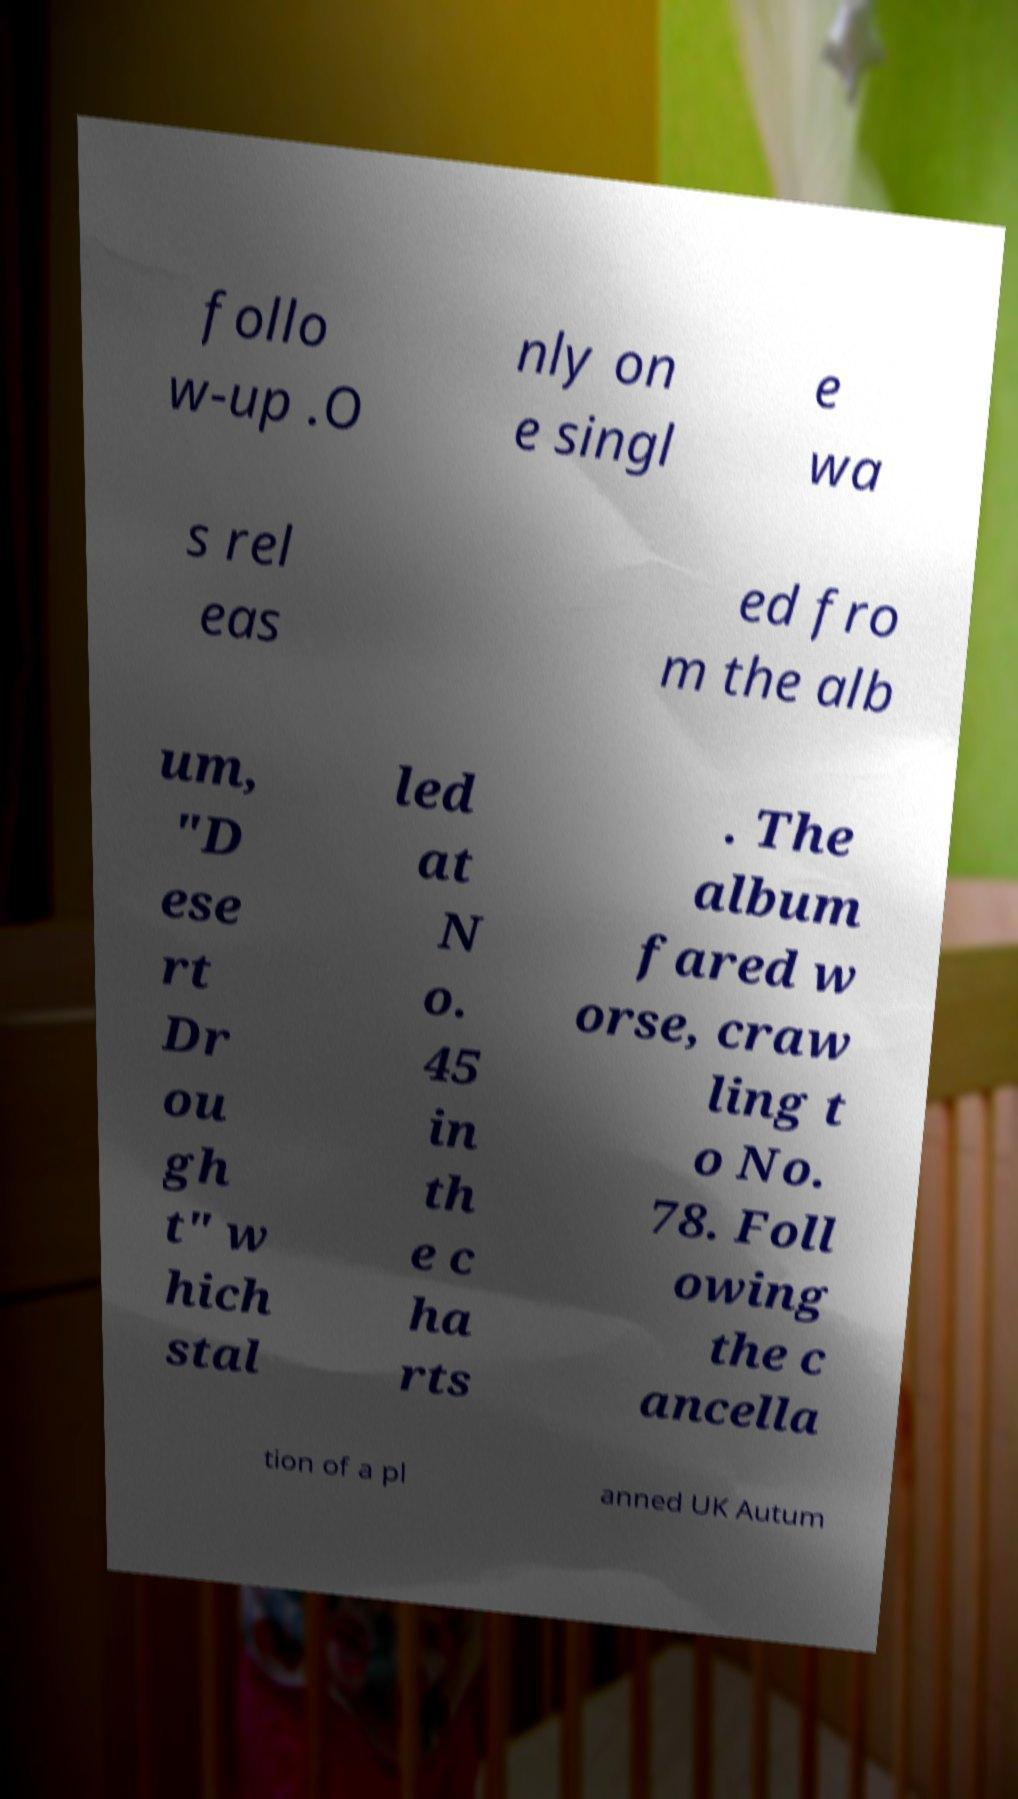There's text embedded in this image that I need extracted. Can you transcribe it verbatim? follo w-up .O nly on e singl e wa s rel eas ed fro m the alb um, "D ese rt Dr ou gh t" w hich stal led at N o. 45 in th e c ha rts . The album fared w orse, craw ling t o No. 78. Foll owing the c ancella tion of a pl anned UK Autum 